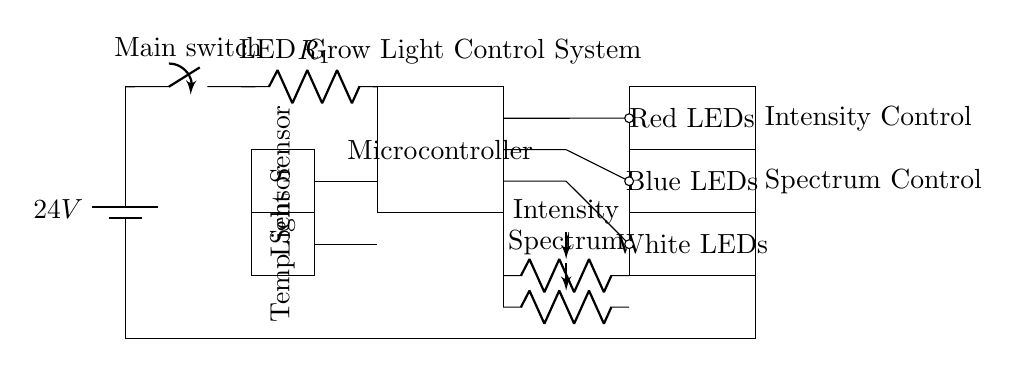What is the voltage of the power supply? The voltage of the power supply is labeled at the battery symbol in the circuit, which shows 24 volts.
Answer: 24 volts What is the purpose of the current limiting resistor? The current limiting resistor is used to limit the amount of current flowing through the LED arrays, preventing them from burning out due to excessive current.
Answer: Current limitation How many types of LEDs are present in this circuit? There are three types of LEDs indicated in the circuit: red, blue, and white; each type is represented by a distinct rectangle for clear identification.
Answer: Three What components are used to control intensity and spectrum? The intensity and spectrum adjustments are achieved using potentiometers, labeled 'Intensity' and 'Spectrum', and placed below the microcontroller in the circuit.
Answer: Potentiometers How many sensors are included in the circuit? The circuit includes two sensors: a light sensor and a temperature sensor, shown as rectangles on the left side of the diagram.
Answer: Two What component provides control of the LED grow light system? The microcontroller, a rectangular component, is responsible for controlling the LED grow light system, integrating inputs from sensors and adjustments from potentiometers.
Answer: Microcontroller What is the function of the main switch? The main switch allows the user to turn the entire circuit on or off, acting as a control point for the power supply to the LEDs.
Answer: On/Off control 